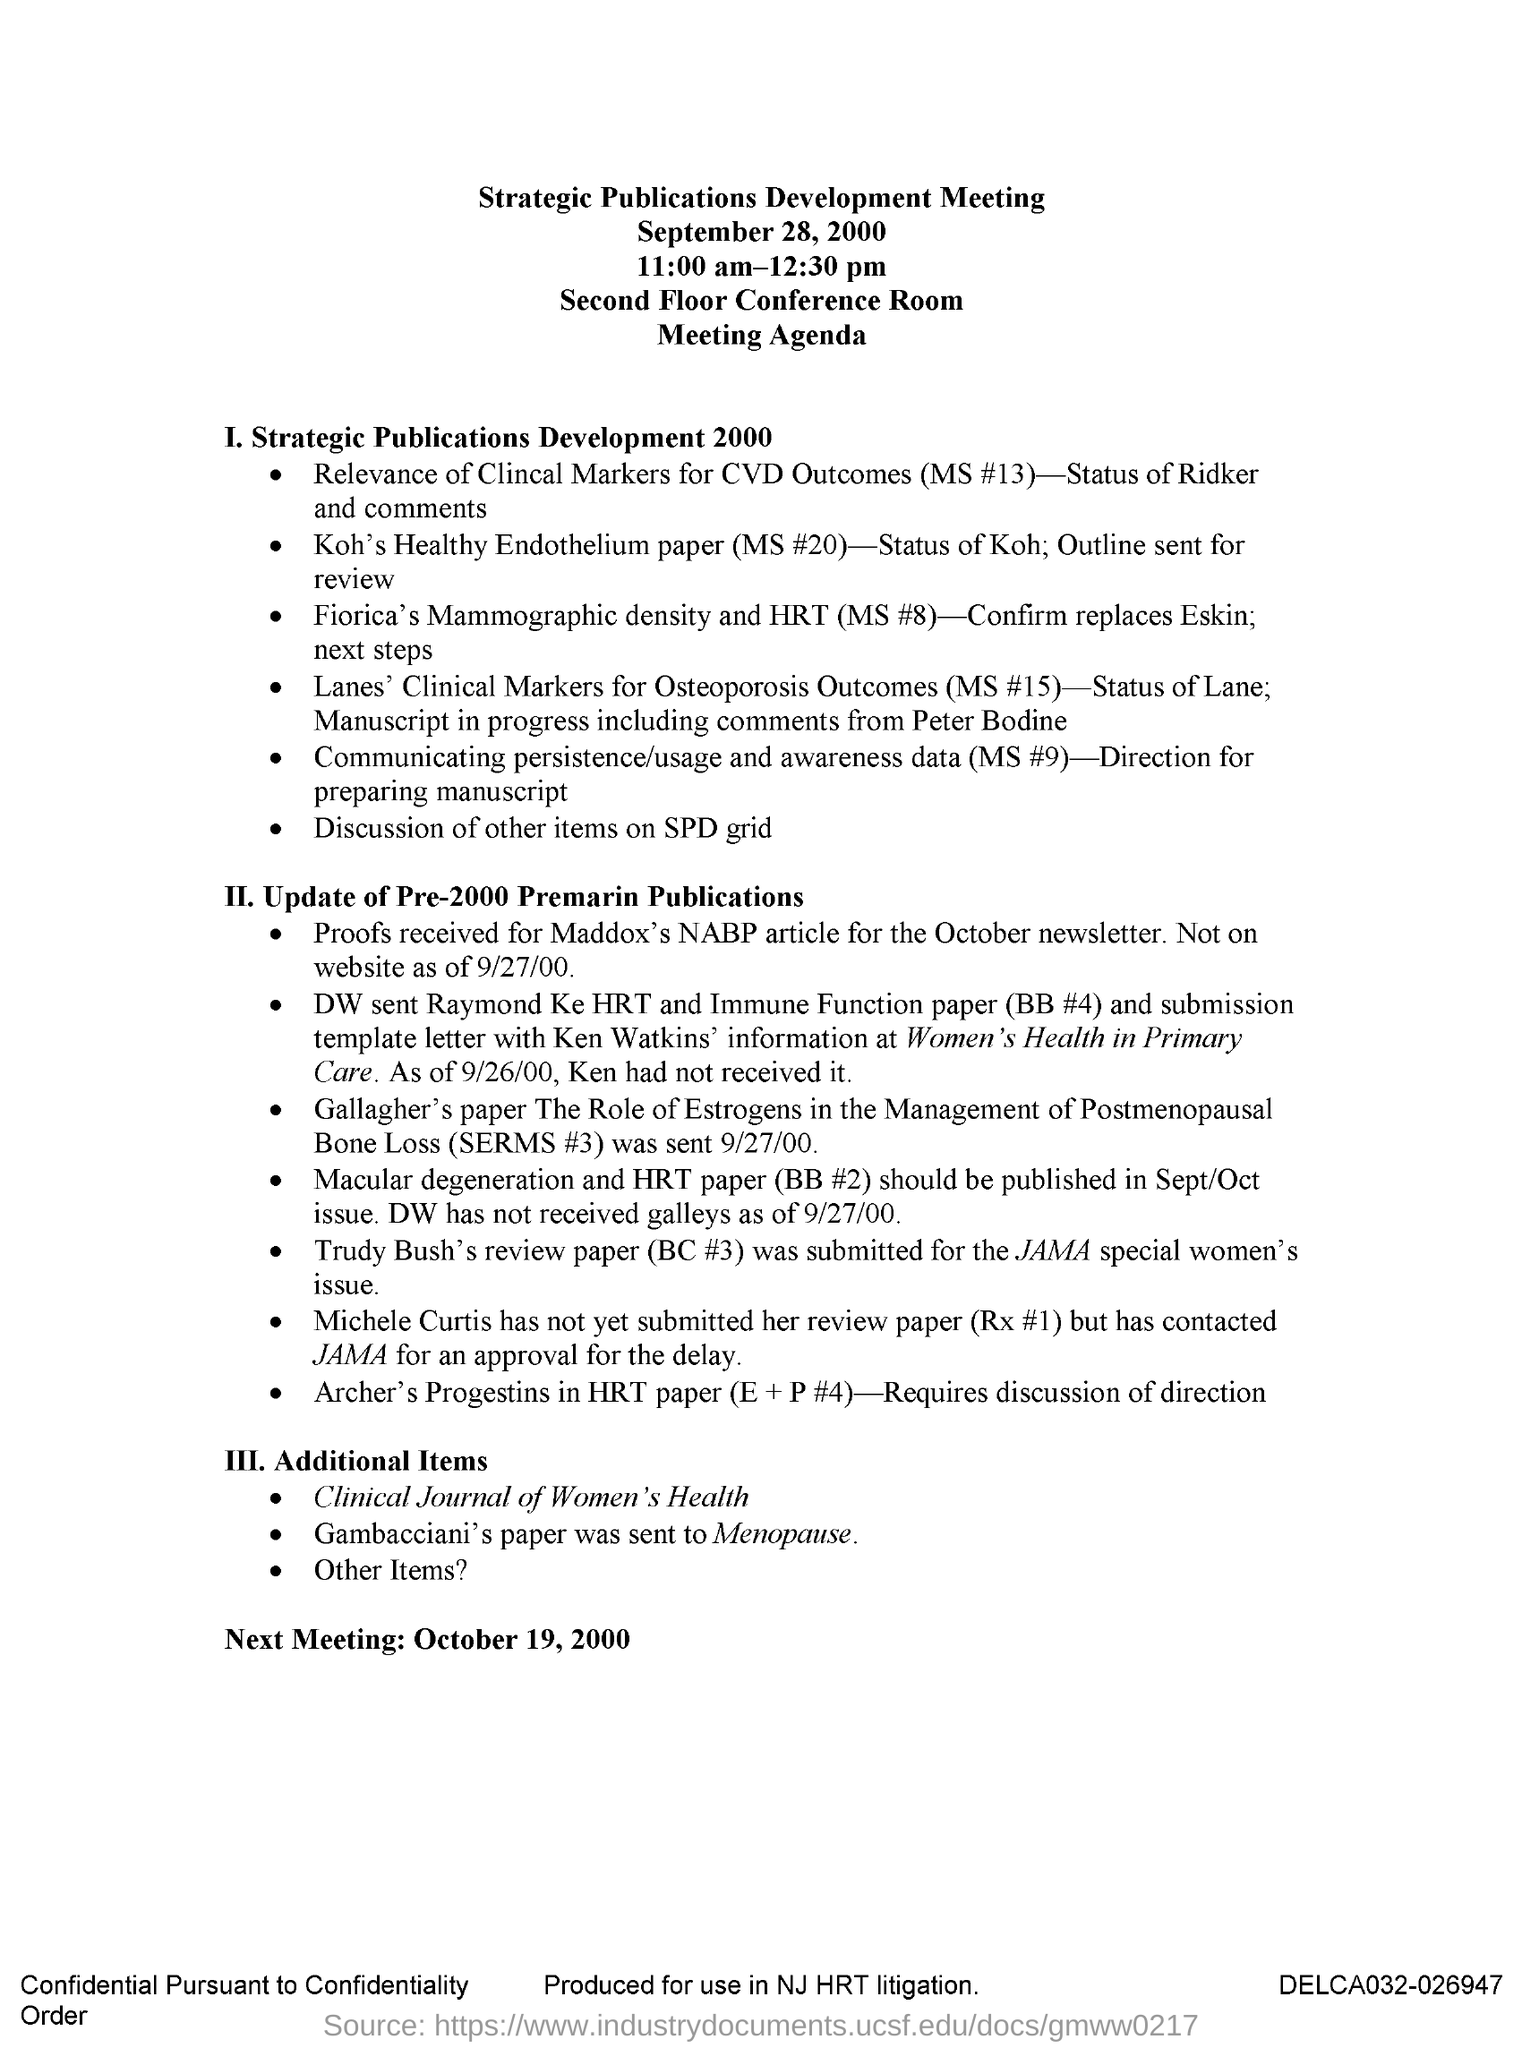When is the Strategic Publications Development Meeting held?
Ensure brevity in your answer.  September 28, 2000. What time is the Strategic Publications Development Meeting held?
Keep it short and to the point. 11-00 am-12:30 pm. Where is the Strategic Publications Development Meeting held?
Make the answer very short. Second Floor Conference Room. When is the Next Meeting?
Make the answer very short. October 19, 2000. 